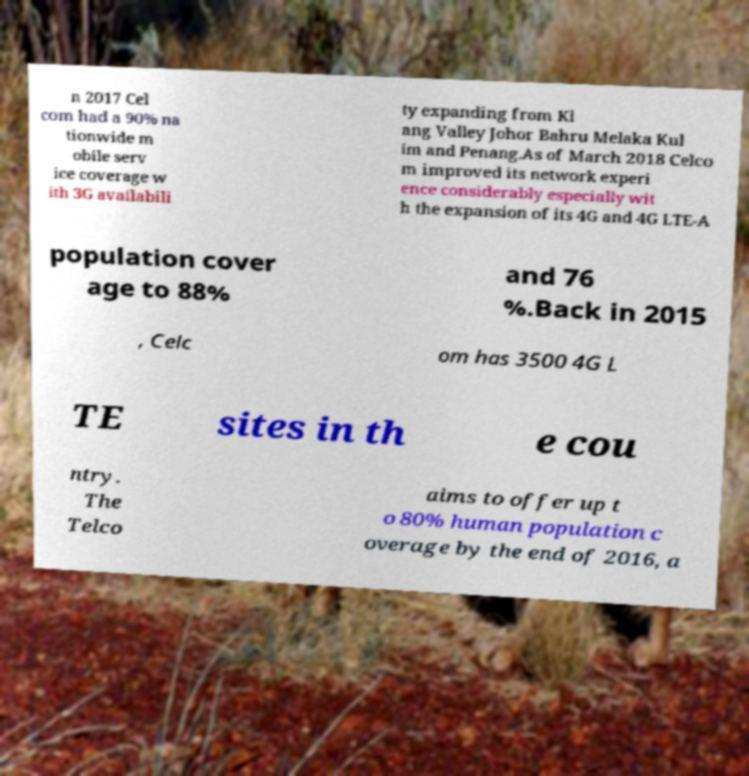There's text embedded in this image that I need extracted. Can you transcribe it verbatim? n 2017 Cel com had a 90% na tionwide m obile serv ice coverage w ith 3G availabili ty expanding from Kl ang Valley Johor Bahru Melaka Kul im and Penang.As of March 2018 Celco m improved its network experi ence considerably especially wit h the expansion of its 4G and 4G LTE-A population cover age to 88% and 76 %.Back in 2015 , Celc om has 3500 4G L TE sites in th e cou ntry. The Telco aims to offer up t o 80% human population c overage by the end of 2016, a 